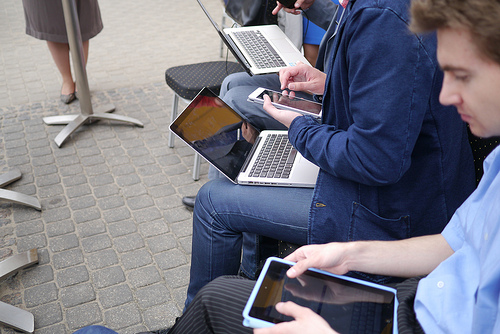Please provide the bounding box coordinate of the region this sentence describes: A computer being held by a human. The more accurate bounding box coordinates might be closer to [0.36, 0.18, 0.60, 0.32], covering the entire area where the computer is visible while being held. 